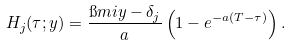<formula> <loc_0><loc_0><loc_500><loc_500>H _ { j } ( \tau ; y ) = \frac { \i m i y - \delta _ { j } } { a } \left ( 1 - e ^ { - a ( T - \tau ) } \right ) .</formula> 